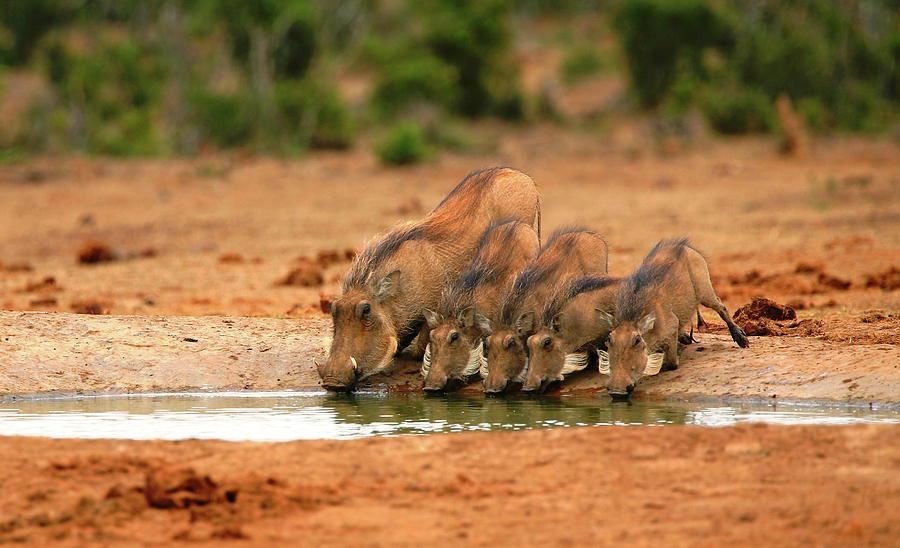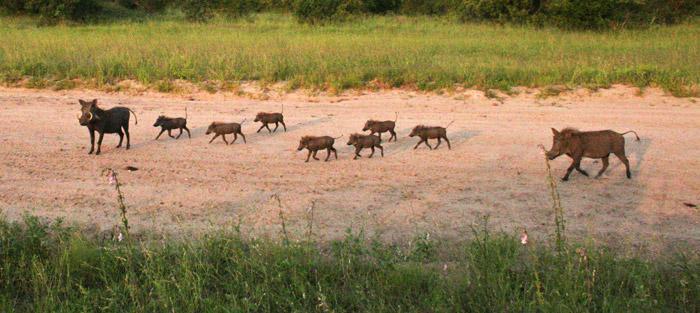The first image is the image on the left, the second image is the image on the right. Considering the images on both sides, is "One of the images has only one wart hog with two tusks." valid? Answer yes or no. No. The first image is the image on the left, the second image is the image on the right. For the images shown, is this caption "There at least one lone animal that has large tusks." true? Answer yes or no. No. 